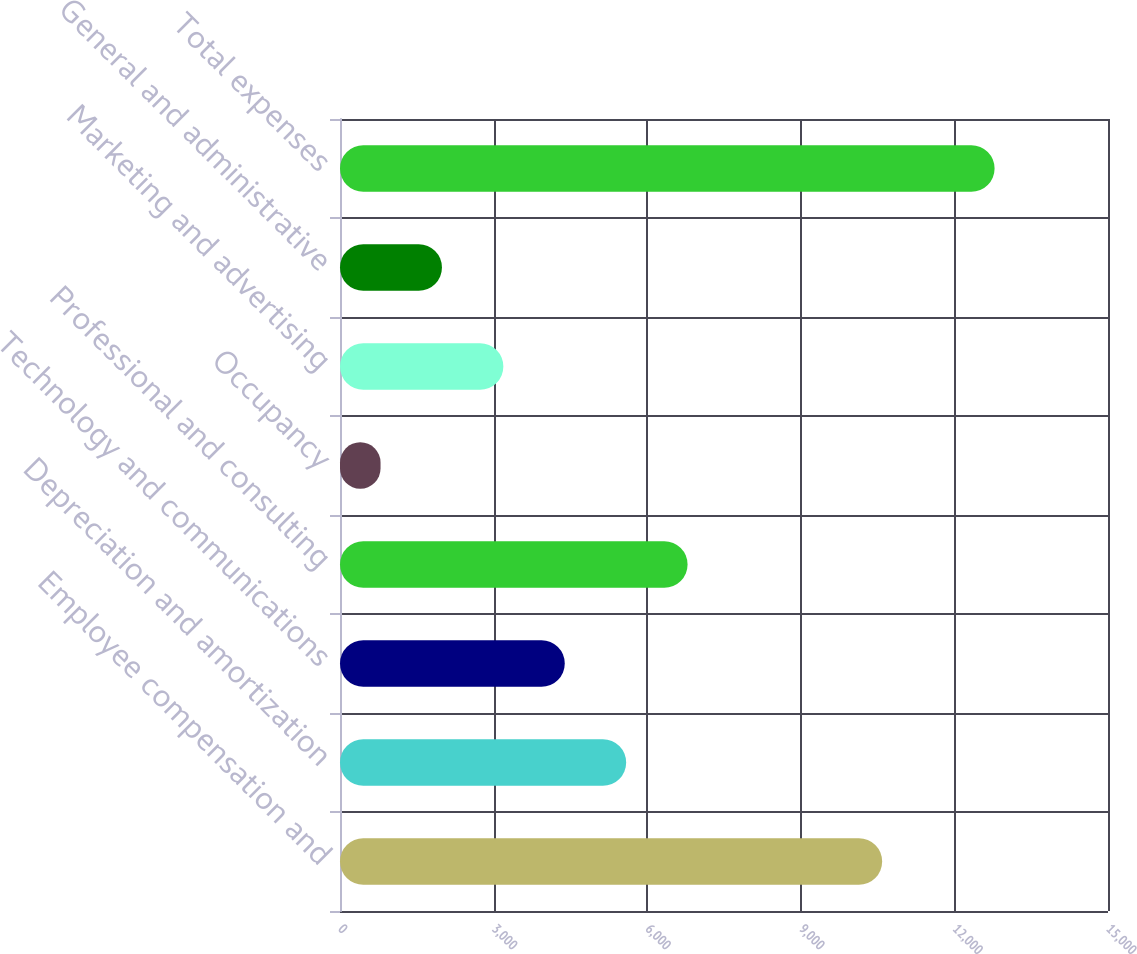<chart> <loc_0><loc_0><loc_500><loc_500><bar_chart><fcel>Employee compensation and<fcel>Depreciation and amortization<fcel>Technology and communications<fcel>Professional and consulting<fcel>Occupancy<fcel>Marketing and advertising<fcel>General and administrative<fcel>Total expenses<nl><fcel>10589<fcel>5589.2<fcel>4389.9<fcel>6788.5<fcel>792<fcel>3190.6<fcel>1991.3<fcel>12785<nl></chart> 